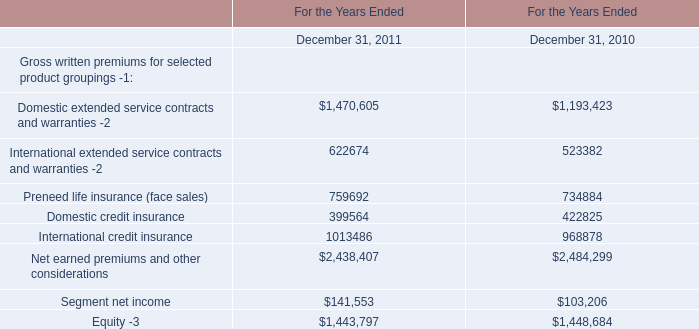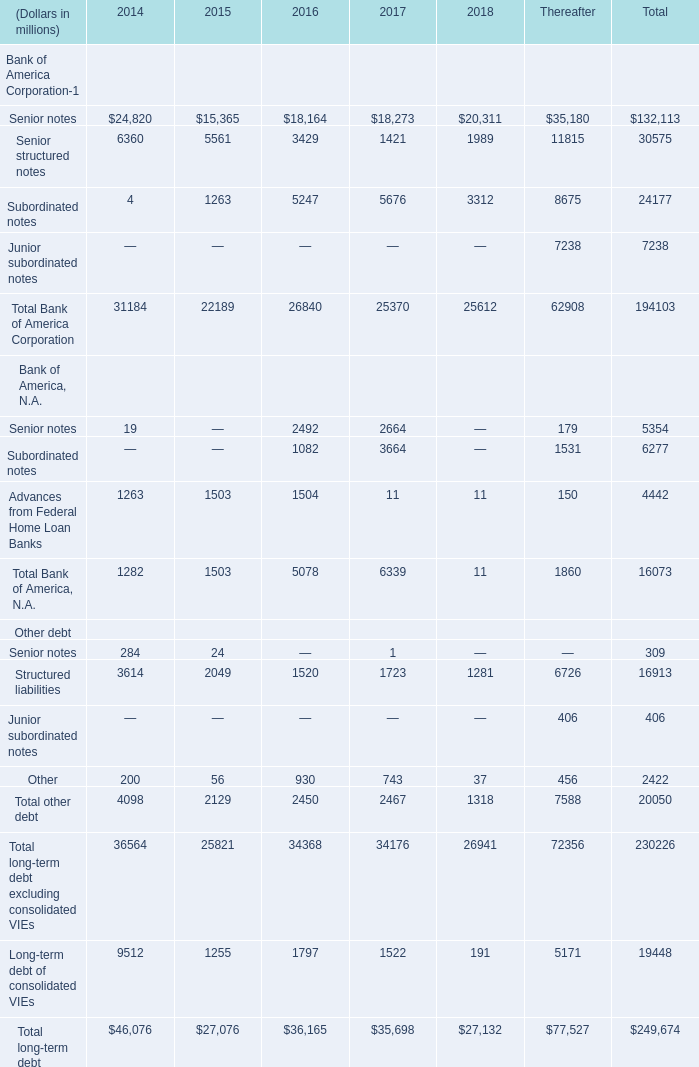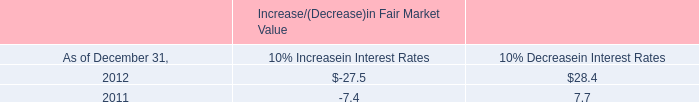what was the ratio of the interest income from 2012 to 2011 
Computations: (29.5 / 37.8)
Answer: 0.78042. 